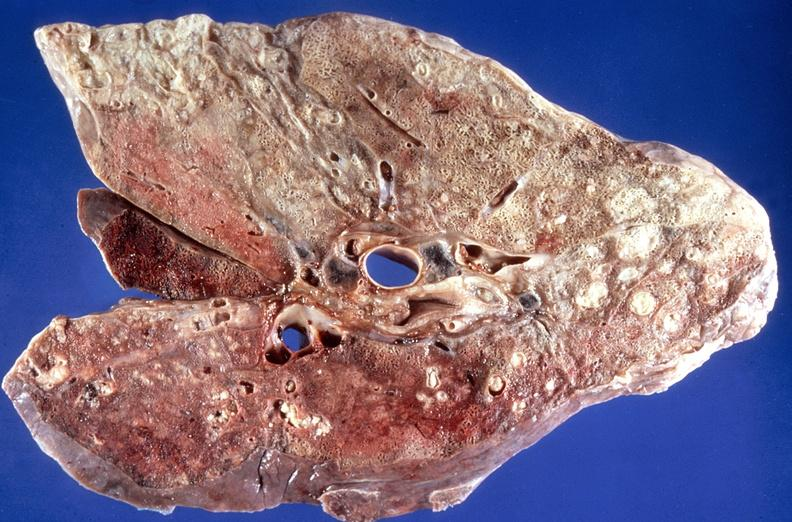where is this?
Answer the question using a single word or phrase. Lung 